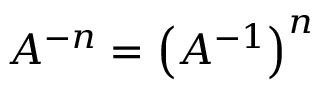Convert formula to latex. <formula><loc_0><loc_0><loc_500><loc_500>A ^ { - n } = \left ( A ^ { - 1 } \right ) ^ { n }</formula> 